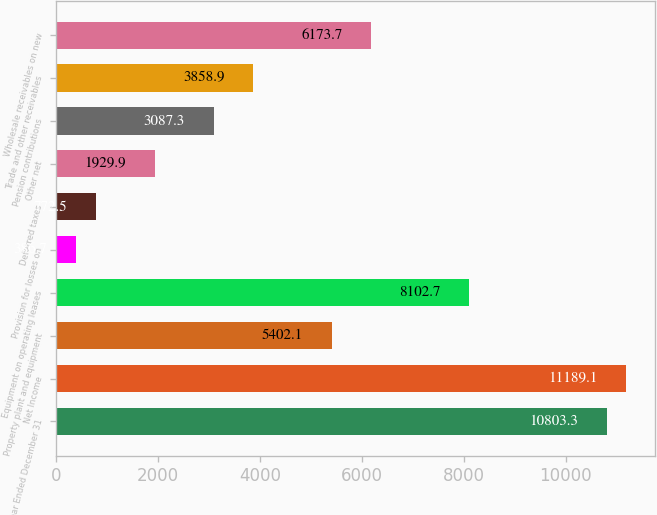Convert chart to OTSL. <chart><loc_0><loc_0><loc_500><loc_500><bar_chart><fcel>Year Ended December 31<fcel>Net Income<fcel>Property plant and equipment<fcel>Equipment on operating leases<fcel>Provision for losses on<fcel>Deferred taxes<fcel>Other net<fcel>Pension contributions<fcel>Trade and other receivables<fcel>Wholesale receivables on new<nl><fcel>10803.3<fcel>11189.1<fcel>5402.1<fcel>8102.7<fcel>386.7<fcel>772.5<fcel>1929.9<fcel>3087.3<fcel>3858.9<fcel>6173.7<nl></chart> 